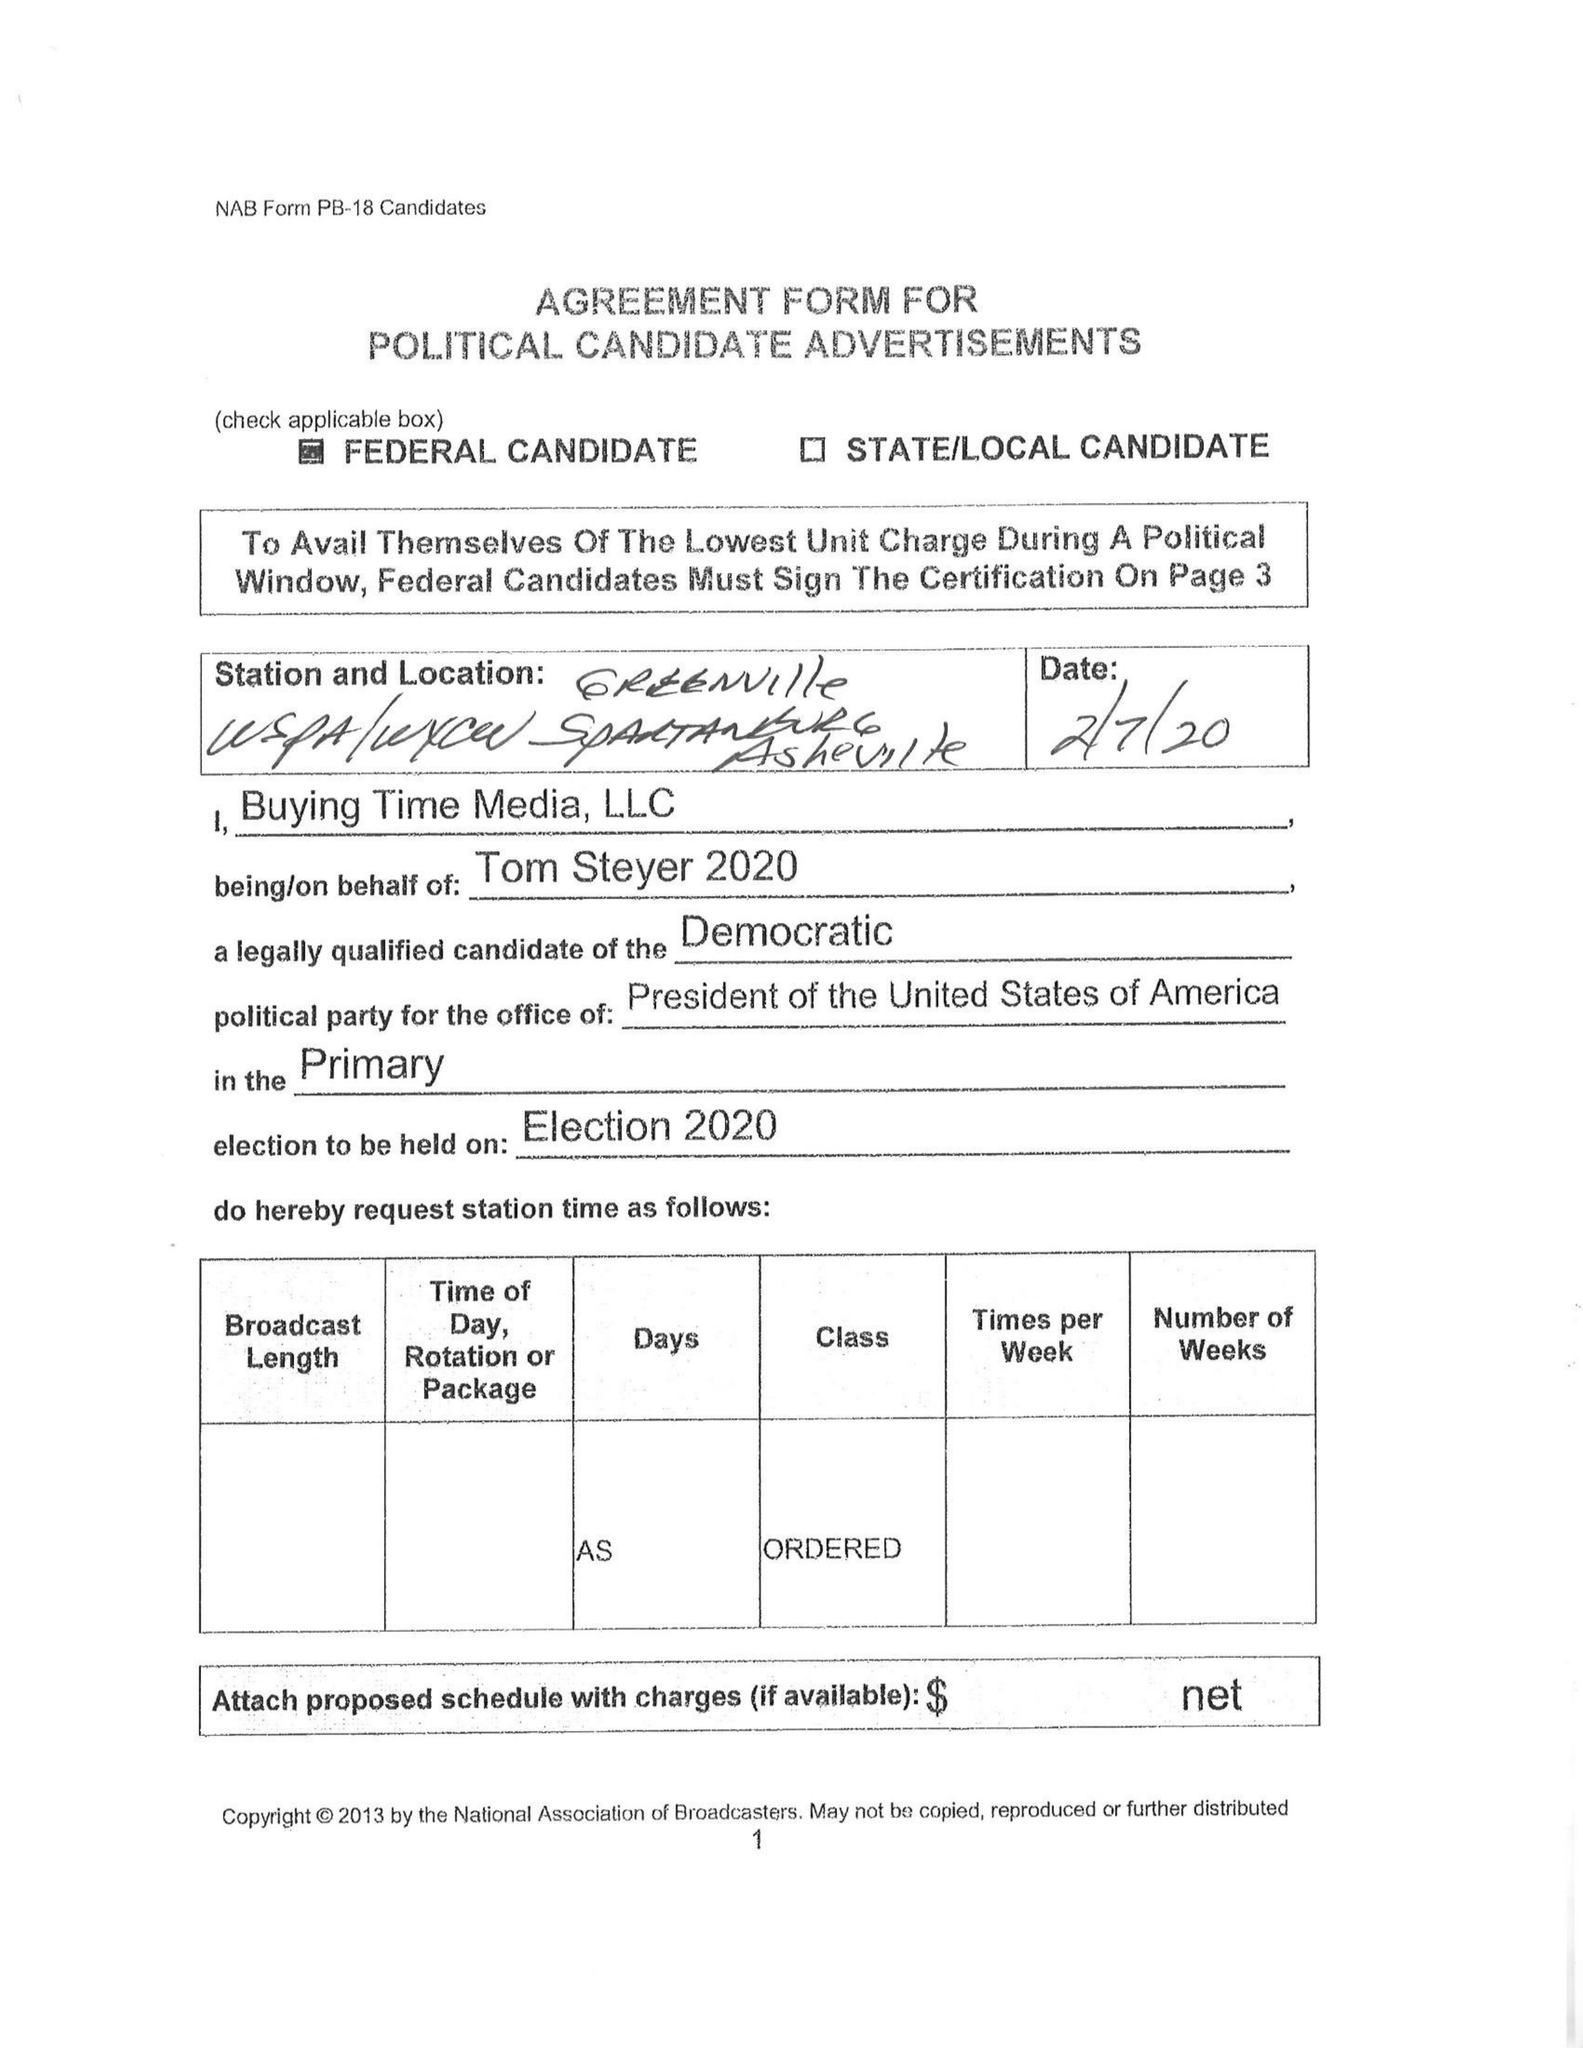What is the value for the flight_from?
Answer the question using a single word or phrase. None 